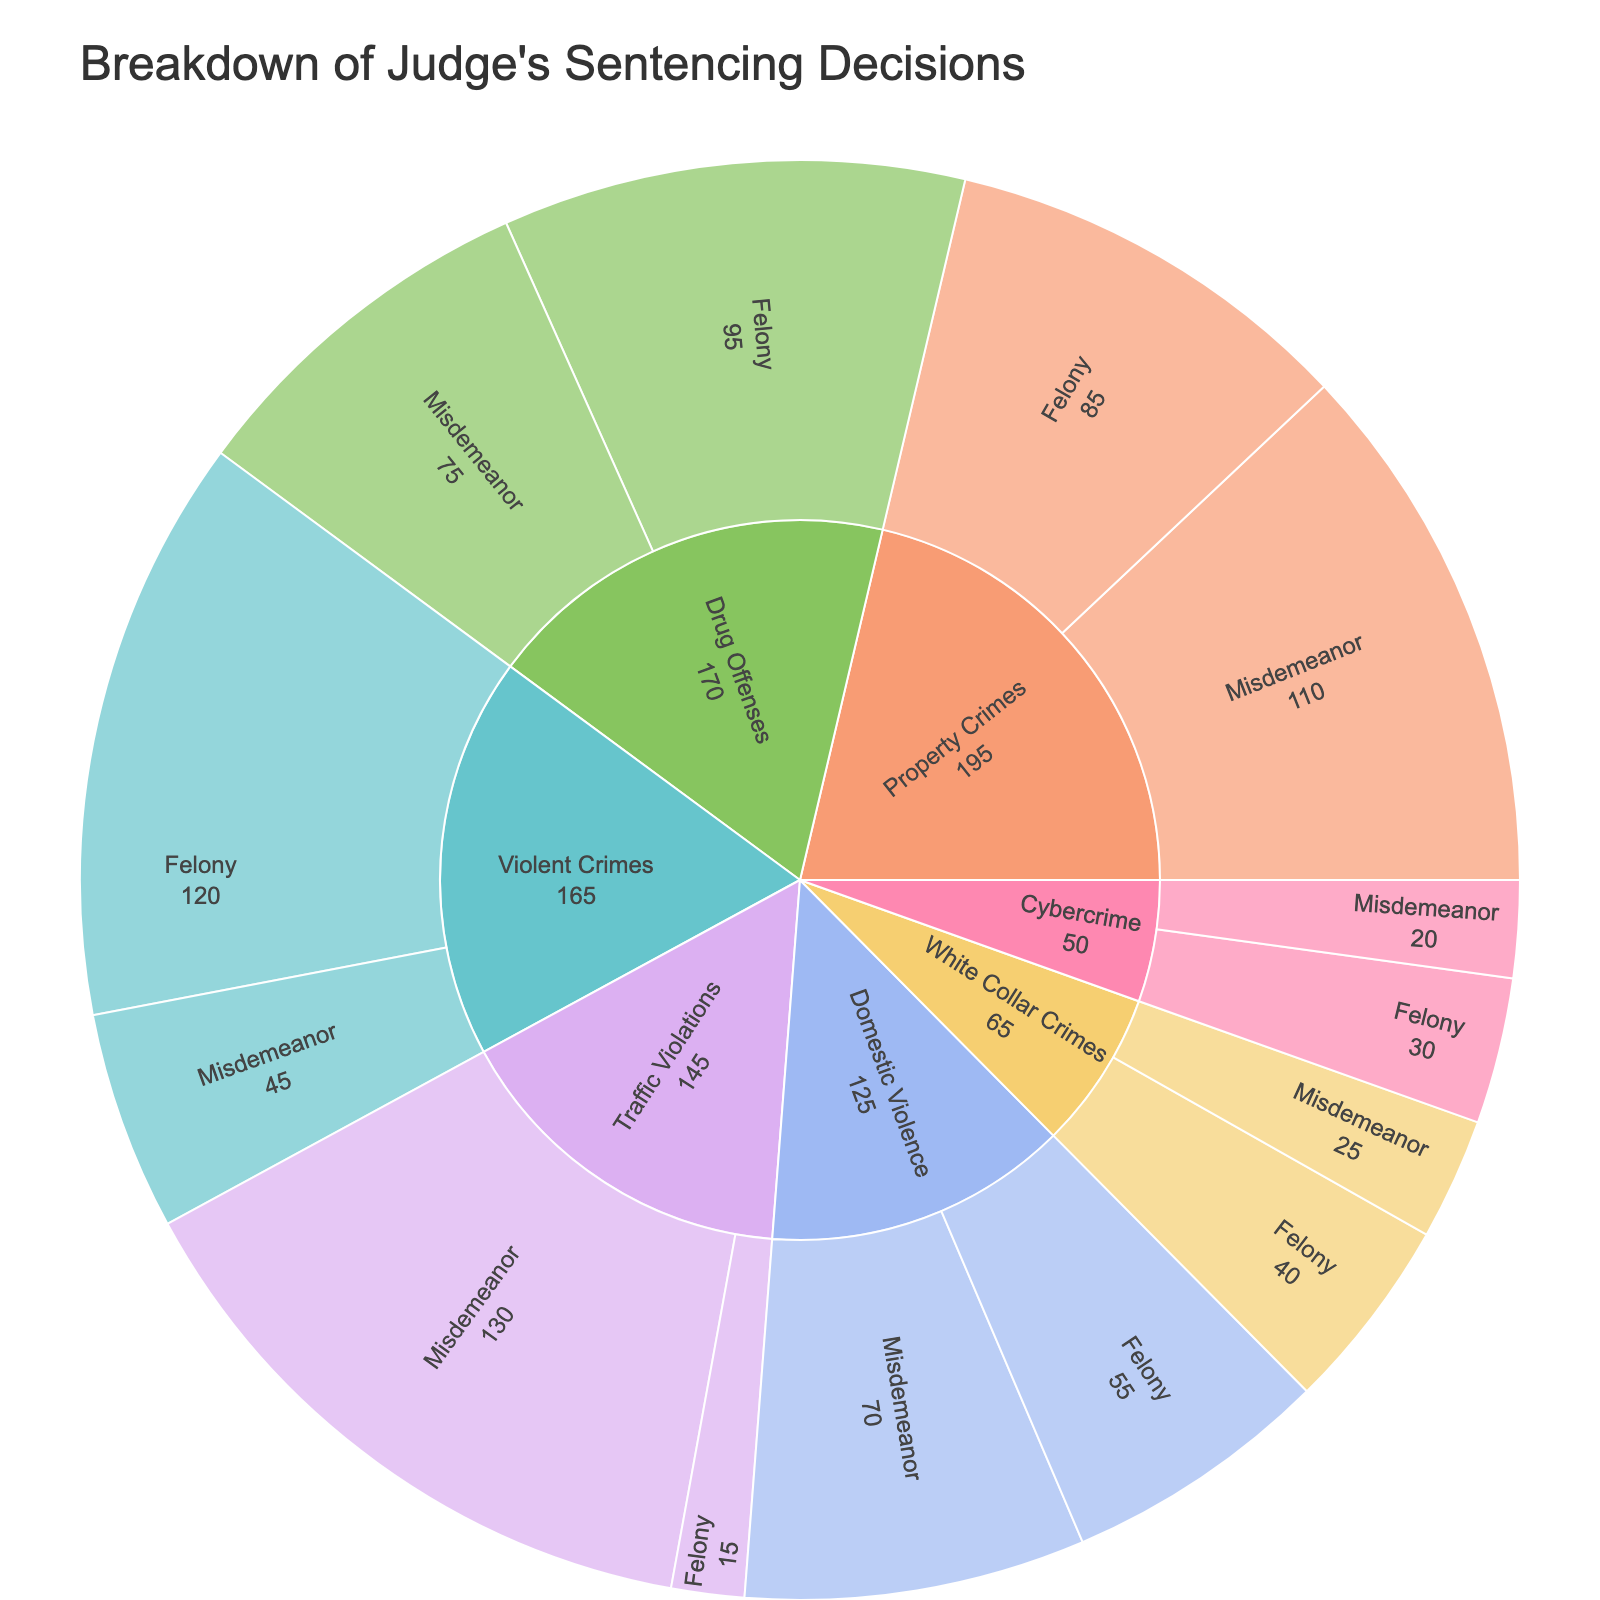What is the total count of traffic violations? To find the total count of traffic violations, look at the segments labeled 'Traffic Violations,' which includes both felony and misdemeanor. Sum the two counts: 15 (Felony) + 130 (Misdemeanor) = 145.
Answer: 145 Which crime type has the highest number of felony cases? Review the 'Felony' segments within each crime type. The counts are 120 (Violent Crimes), 85 (Property Crimes), 95 (Drug Offenses), 40 (White Collar Crimes), 15 (Traffic Violations), 55 (Domestic Violence), and 30 (Cybercrime). The highest number is 120 for Violent Crimes.
Answer: Violent Crimes What is the difference in count between misdemeanors and felonies for property crimes? Identify the counts for misdemeanors and felonies within Property Crimes: 110 (Misdemeanor) and 85 (Felony). Calculate the difference: 110 - 85 = 25.
Answer: 25 What is the proportion of drug offenses that are felonies compared to the total drug offenses? First, find the counts for both drug offense categories: 95 (Felony) and 75 (Misdemeanor). Calculate the total: 95 + 75 = 170. Then, determine the proportion of felonies: 95 / 170 ≈ 0.558 or 55.8%.
Answer: 55.8% How are the counts of white collar crimes distributed between felonies and misdemeanors? Locate the 'White Collar Crimes' section in the sunburst plot. The counts are 40 (Felony) and 25 (Misdemeanor).
Answer: 40 Felonies and 25 Misdemeanors Which crime type has the least number of cases, and what is the total count for this type? Compare the total counts for each crime type by summing the felony and misdemeanor cases: Cybercrime (30+20=50), White Collar Crimes (40+25=65), Traffic Violations (15+130=145), etc. The least total number, 50, is for Cybercrime.
Answer: Cybercrime, 50 What is the total count of all misdemeanors regardless of crime type? Add the counts of misdemeanors for all crime types: 45 (Violent Crimes) + 110 (Property Crimes) + 75 (Drug Offenses) + 25 (White Collar Crimes) + 130 (Traffic Violations) + 70 (Domestic Violence) + 20 (Cybercrime) = 475.
Answer: 475 Compare the total counts of violent crimes against property crimes. Which type has more, and by how much? Sum the counts for both categories: Violent Crimes (120+45=165) and Property Crimes (85+110=195). The difference is 195 - 165 = 30. Property Crimes has more cases by 30.
Answer: Property Crimes, 30 